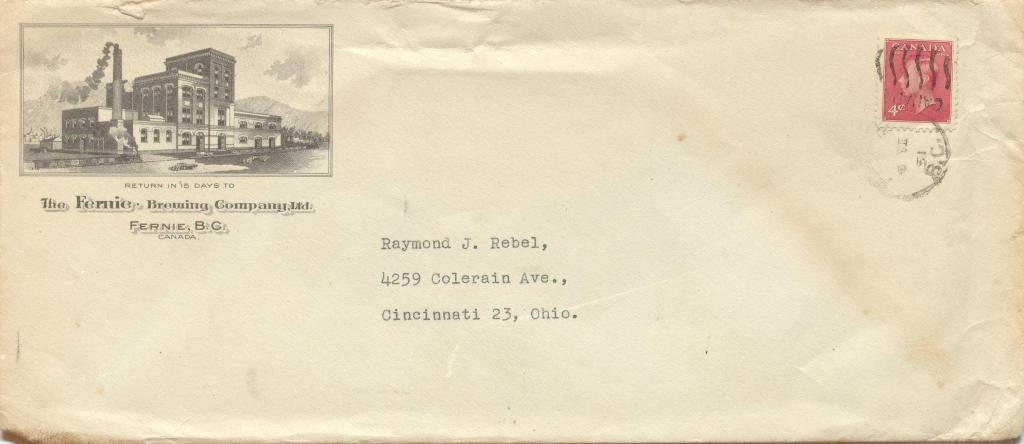<image>
Give a short and clear explanation of the subsequent image. an envelope addressed to Raymond J. Rebel of Cincinnati 